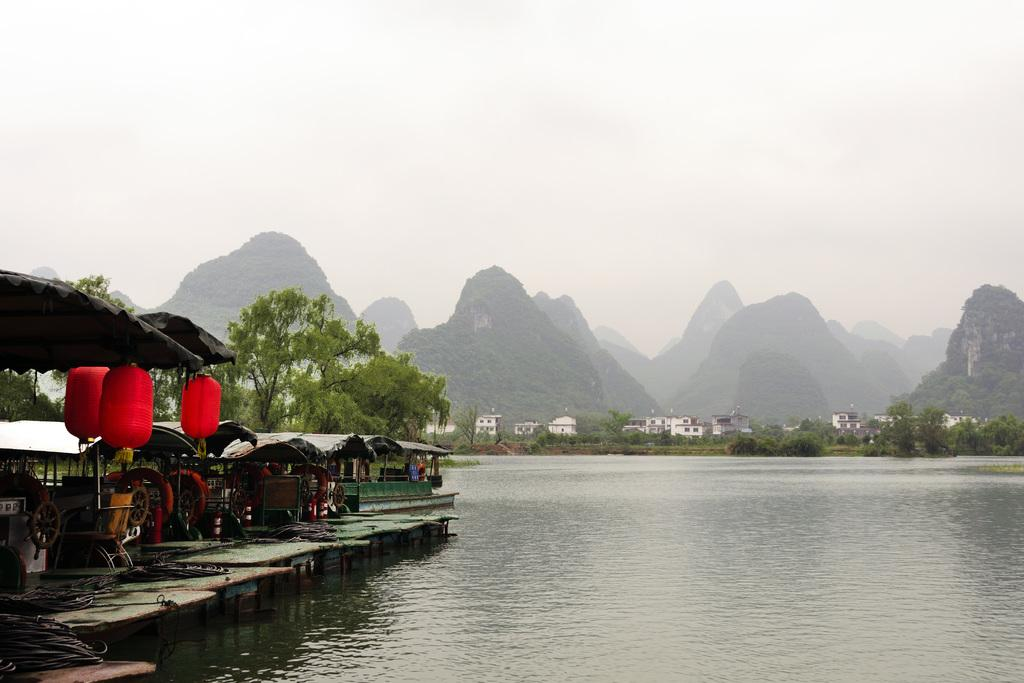What can be seen in the left corner of the image? There are boats in the left corner of the image. What is beside the boats? There is water beside the boats. What type of natural scenery is visible in the background of the image? There are trees, buildings, and mountains in the background of the image. What type of songs can be heard coming from the boats in the image? There is no indication in the image that any songs are being played or heard from the boats. How many beds are visible in the image? There are no beds present in the image. 